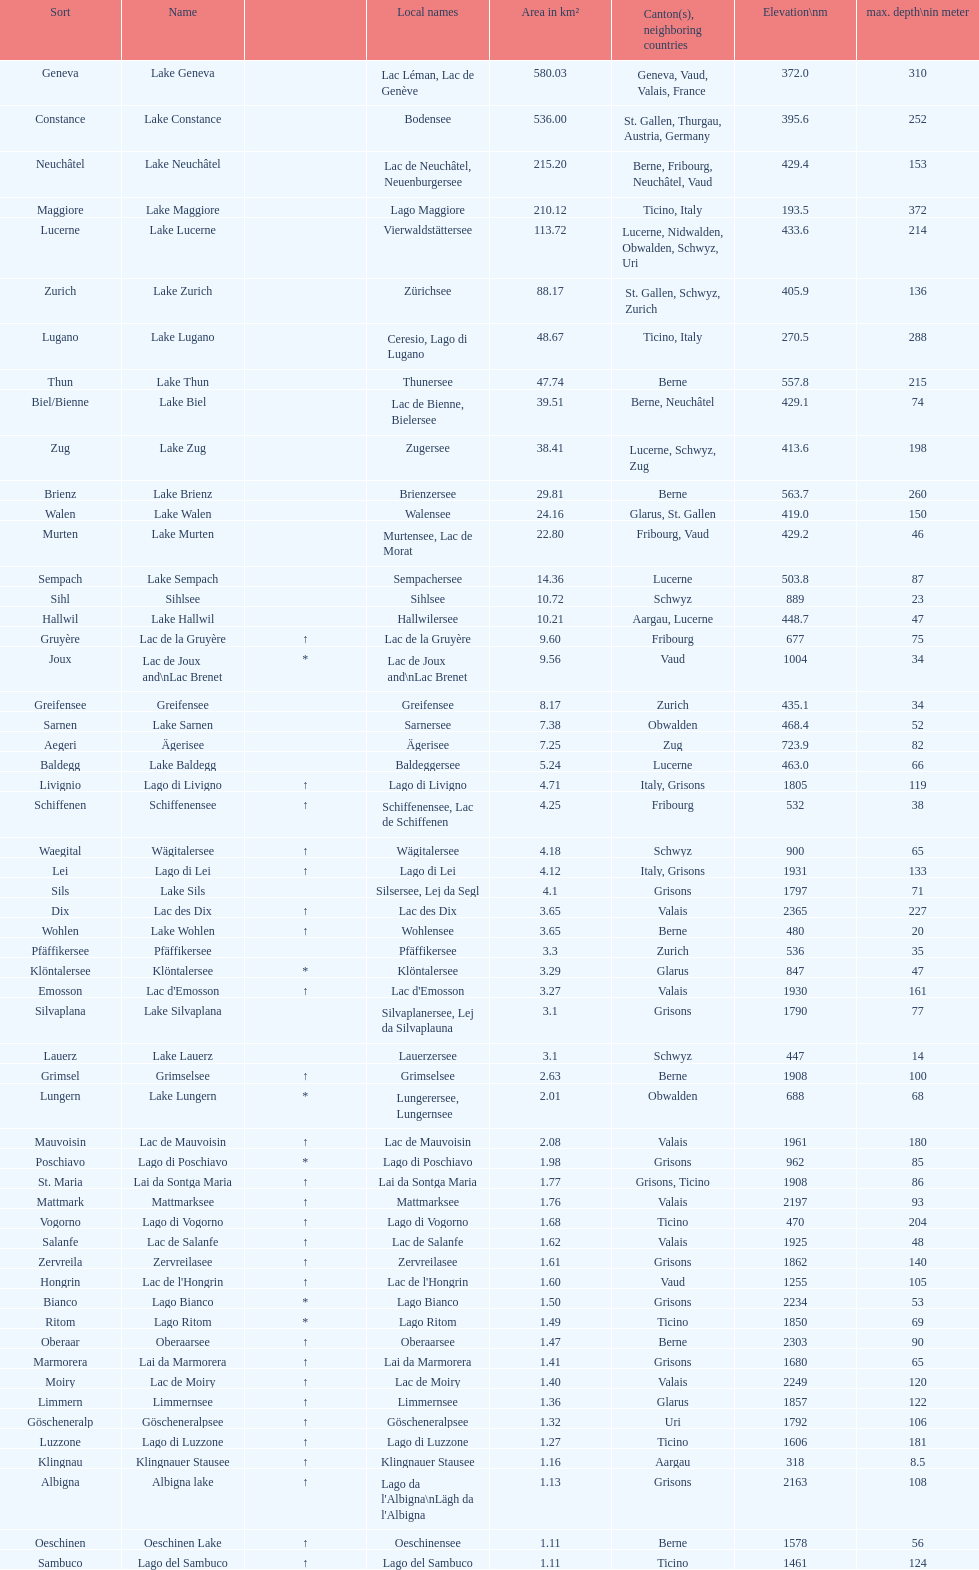What lake has the next highest elevation after lac des dix? Oberaarsee. 